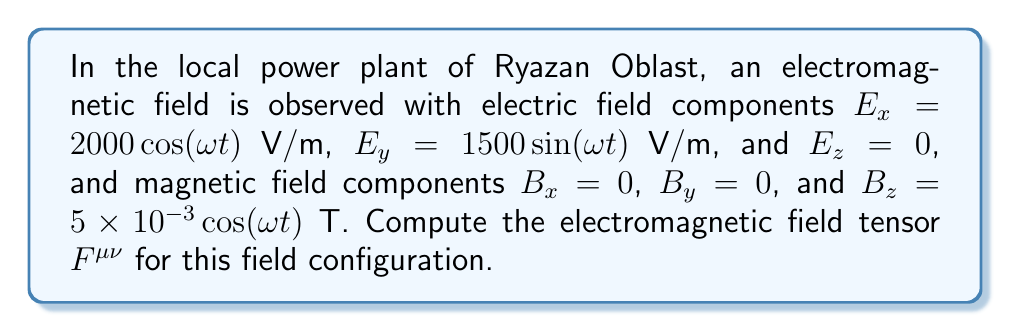Show me your answer to this math problem. To compute the electromagnetic field tensor $F^{\mu\nu}$, we need to follow these steps:

1) The electromagnetic field tensor in SI units is defined as:

   $$F^{\mu\nu} = \begin{pmatrix}
   0 & -E_x/c & -E_y/c & -E_z/c \\
   E_x/c & 0 & -B_z & B_y \\
   E_y/c & B_z & 0 & -B_x \\
   E_z/c & -B_y & B_x & 0
   \end{pmatrix}$$

   where $c$ is the speed of light.

2) We are given:
   $E_x = 2000\cos(ωt)$ V/m
   $E_y = 1500\sin(ωt)$ V/m
   $E_z = 0$ V/m
   $B_x = 0$ T
   $B_y = 0$ T
   $B_z = 5\times10^{-3}\cos(ωt)$ T

3) Let's substitute these values into the tensor:

   $$F^{\mu\nu} = \begin{pmatrix}
   0 & -\frac{2000\cos(ωt)}{c} & -\frac{1500\sin(ωt)}{c} & 0 \\
   \frac{2000\cos(ωt)}{c} & 0 & -5\times10^{-3}\cos(ωt) & 0 \\
   \frac{1500\sin(ωt)}{c} & 5\times10^{-3}\cos(ωt) & 0 & 0 \\
   0 & 0 & 0 & 0
   \end{pmatrix}$$

4) The speed of light $c$ is approximately $3\times10^8$ m/s. Let's simplify the fractions:

   $\frac{2000}{c} \approx 6.67\times10^{-6}$
   $\frac{1500}{c} \approx 5\times10^{-6}$

5) Substituting these values, we get our final electromagnetic field tensor:

   $$F^{\mu\nu} = \begin{pmatrix}
   0 & -6.67\times10^{-6}\cos(ωt) & -5\times10^{-6}\sin(ωt) & 0 \\
   6.67\times10^{-6}\cos(ωt) & 0 & -5\times10^{-3}\cos(ωt) & 0 \\
   5\times10^{-6}\sin(ωt) & 5\times10^{-3}\cos(ωt) & 0 & 0 \\
   0 & 0 & 0 & 0
   \end{pmatrix}$$

This tensor fully describes the electromagnetic field at the Ryazan Oblast power plant.
Answer: $$F^{\mu\nu} = \begin{pmatrix}
0 & -6.67\times10^{-6}\cos(ωt) & -5\times10^{-6}\sin(ωt) & 0 \\
6.67\times10^{-6}\cos(ωt) & 0 & -5\times10^{-3}\cos(ωt) & 0 \\
5\times10^{-6}\sin(ωt) & 5\times10^{-3}\cos(ωt) & 0 & 0 \\
0 & 0 & 0 & 0
\end{pmatrix}$$ 